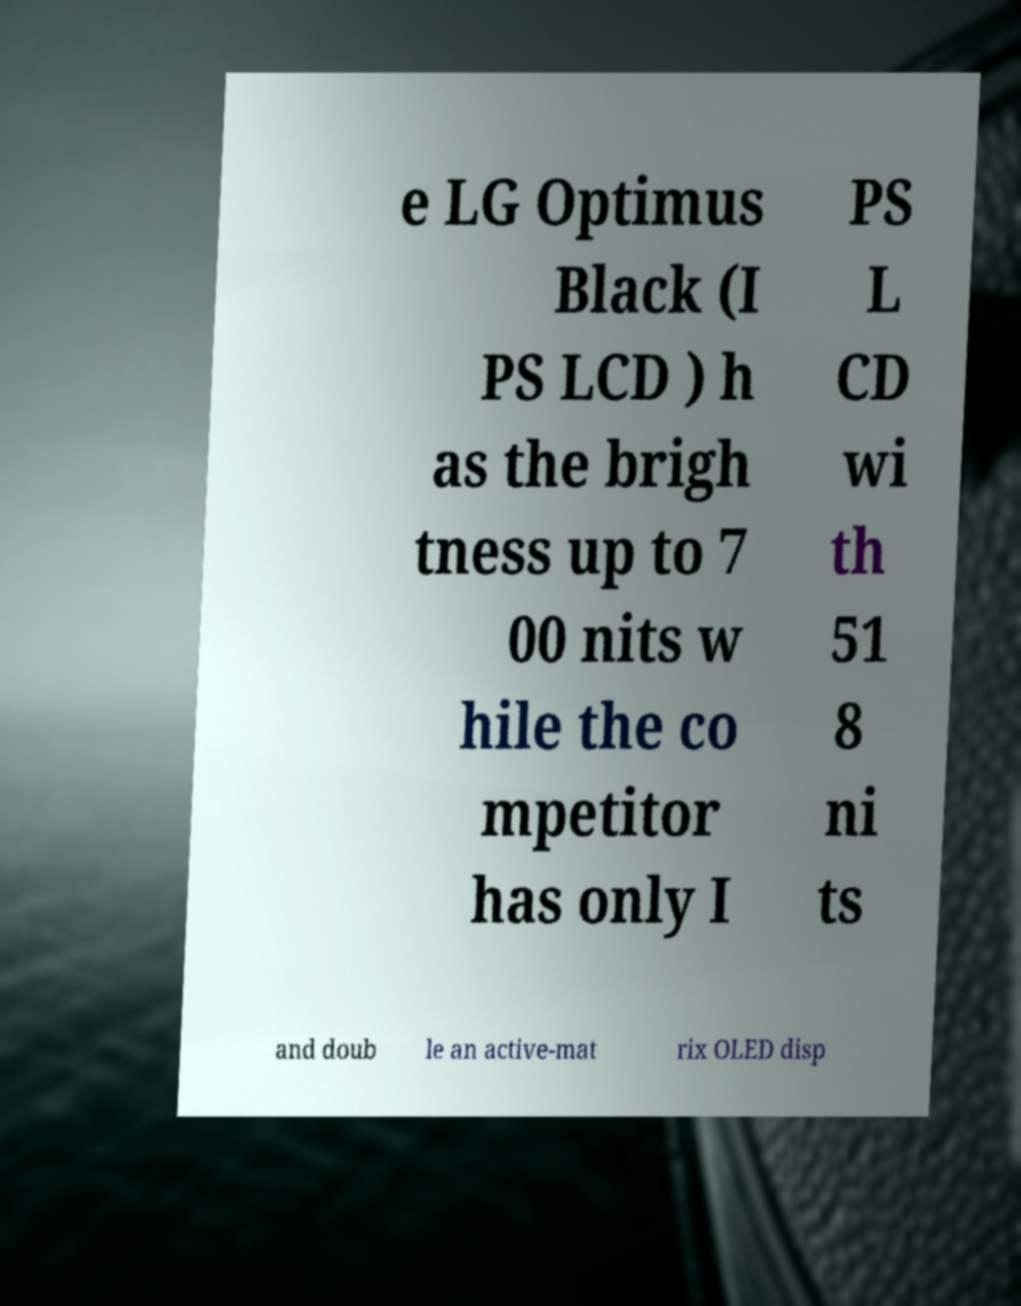Please read and relay the text visible in this image. What does it say? e LG Optimus Black (I PS LCD ) h as the brigh tness up to 7 00 nits w hile the co mpetitor has only I PS L CD wi th 51 8 ni ts and doub le an active-mat rix OLED disp 